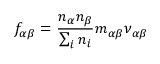<formula> <loc_0><loc_0><loc_500><loc_500>f _ { \alpha \beta } = \frac { n _ { \alpha } n _ { \beta } } { \sum _ { i } n _ { i } } m _ { \alpha \beta } \nu _ { \alpha \beta }</formula> 